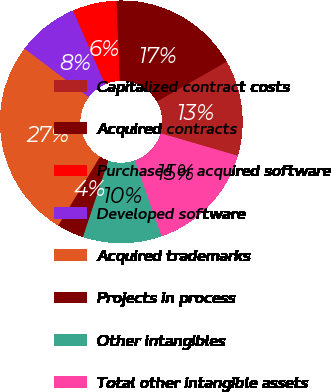Convert chart. <chart><loc_0><loc_0><loc_500><loc_500><pie_chart><fcel>Capitalized contract costs<fcel>Acquired contracts<fcel>Purchased or acquired software<fcel>Developed software<fcel>Acquired trademarks<fcel>Projects in process<fcel>Other intangibles<fcel>Total other intangible assets<nl><fcel>12.79%<fcel>17.39%<fcel>5.88%<fcel>8.18%<fcel>26.6%<fcel>3.58%<fcel>10.49%<fcel>15.09%<nl></chart> 